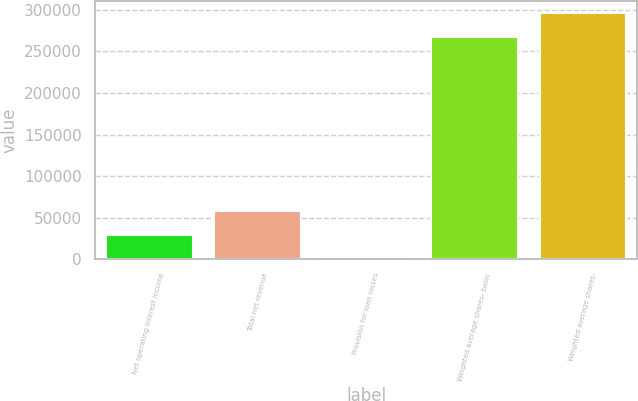Convert chart. <chart><loc_0><loc_0><loc_500><loc_500><bar_chart><fcel>Net operating interest income<fcel>Total net revenue<fcel>Provision for loan losses<fcel>Weighted average shares- basic<fcel>Weighted average shares-<nl><fcel>29378.7<fcel>58316.9<fcel>440.6<fcel>267291<fcel>296229<nl></chart> 